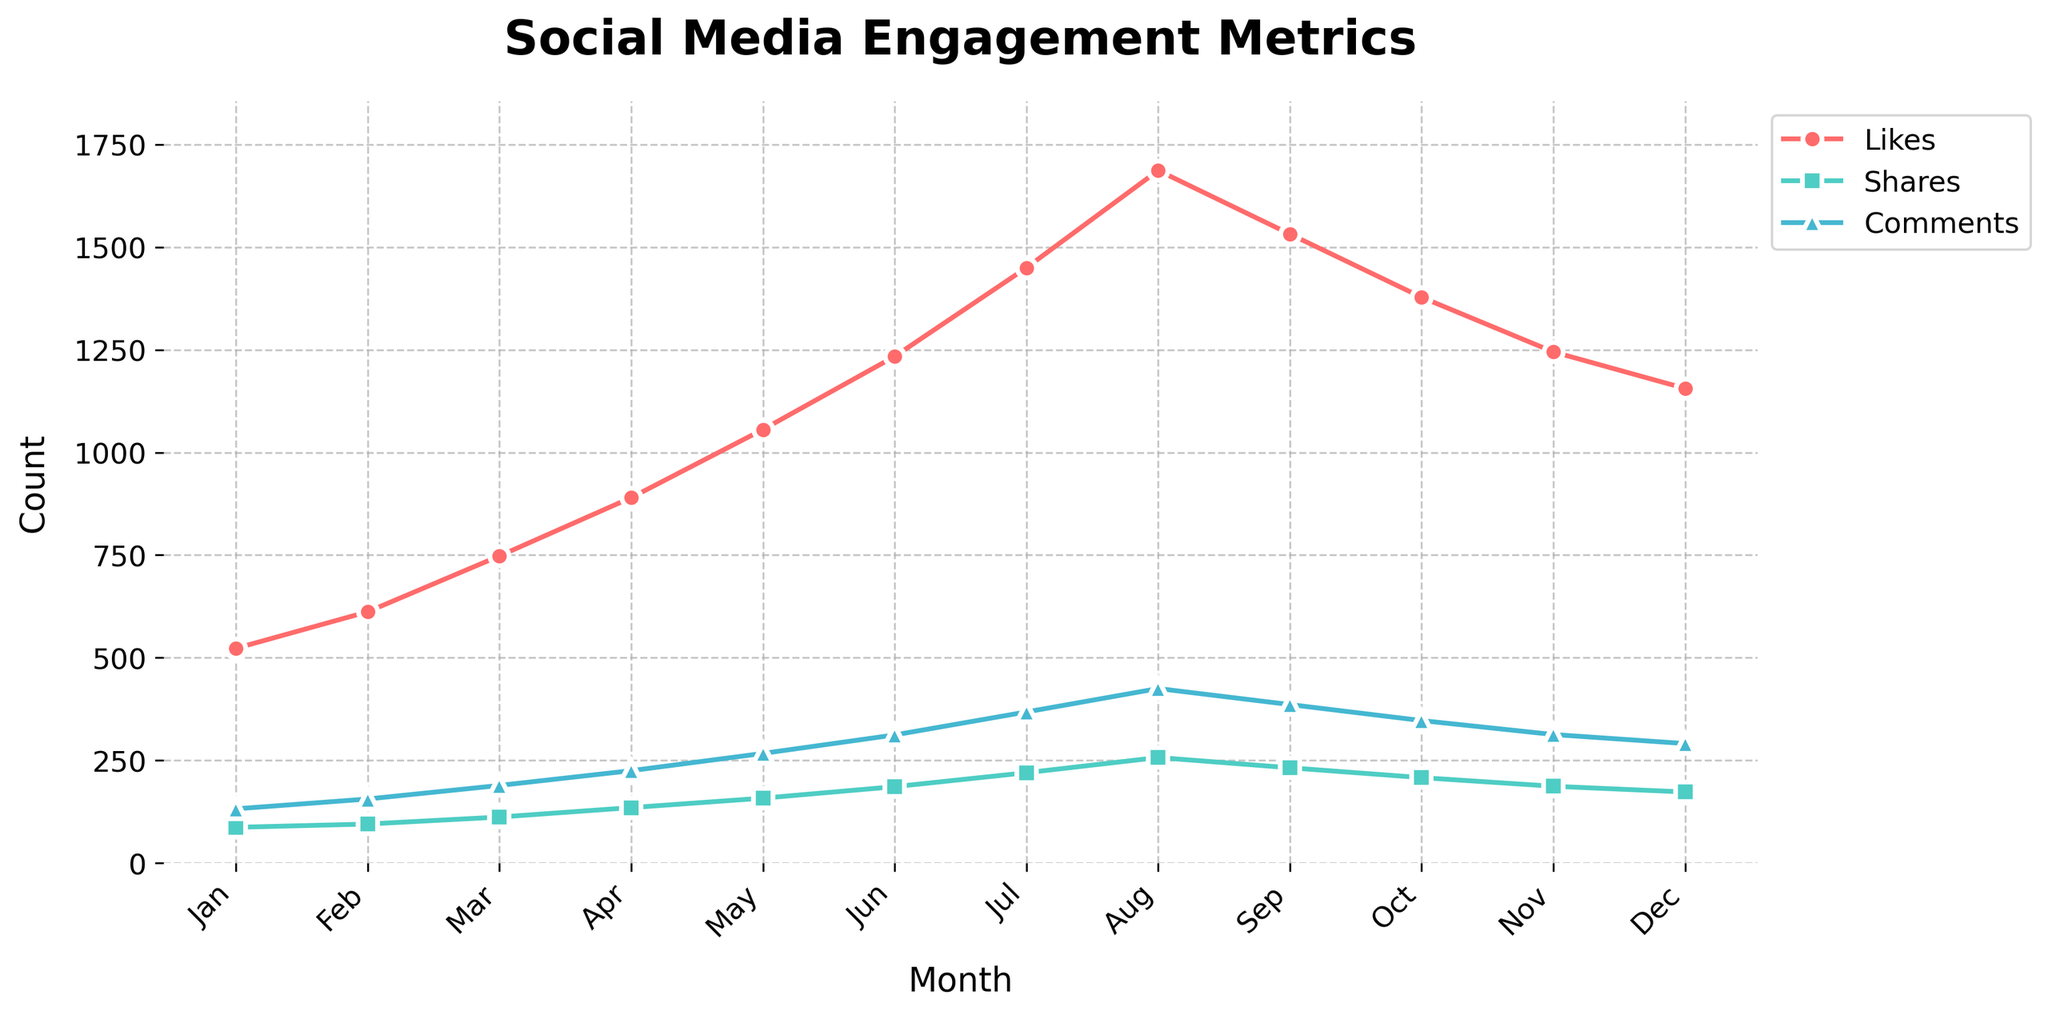What's the overall trend for Likes over the past 12 months? The overall trend can be determined by looking at the line representing Likes. Observing each month's data point, we can see the number of Likes generally increases from January to August and then decreases slightly towards December. This indicates an upward trend followed by a slight decline.
Answer: Increasing with a slight decline towards the end Which month had the highest number of Comments? To determine the month with the highest number of Comments, look for the peak point in the line representing Comments. The peak occurs in August, where the number of Comments is the highest.
Answer: August By how much did Shares increase from January to July? To find out the increase in Shares from January to July, look at the Shares values in these two months. In January, Shares are 87. In July, Shares are 220. The increase is calculated as 220 - 87 = 133.
Answer: 133 How does the number of Likes in June compare to September? Comparing the Likes in June and September involves looking at those two points on the Likes line. June has 1234 Likes, and September has 1532 Likes. Since 1532 is greater than 1234, Likes in September are higher than in June.
Answer: Higher in September What is the average number of Comments in the first half of the year? To calculate the average number of Comments in the first half of the year (January to June), add the number of Comments for each month and then divide by 6. (132 + 156 + 189 + 225 + 267 + 312) / 6 = 208.5.
Answer: 208.5 What is the color used for representing Likes? The color representing Likes can be identified by looking at the visual attribute (color) of the line for Likes. The line representing Likes is red.
Answer: Red Which month saw the largest increase in Shares over the previous month? To determine the largest month-over-month increase in Shares, calculate the difference in Shares for each consecutive month and identify the maximum increase. The differences are 8, 17, 23, 23, 28, 34, 37, -25, -24, -21. The maximum increase is by 37 from July to August.
Answer: July to August What is the difference between the highest and lowest number of Likes in any month? Finding the highest and lowest number of Likes involves identifying the maximum and minimum values on the Likes line. The highest number is 1687 (August) and the lowest is 523 (January). The difference is 1687 - 523 = 1164.
Answer: 1164 How did the Comments change from June to December? To understand the change in Comments from June to December, observe the Comments values in these months. June has 312 Comments, and December has 291 Comments. The change is 291 - 312 = -21, indicating a decrease.
Answer: Decreased by 21 In which two consecutive months did Shares experience no change? Check the values for Shares to identify any two consecutive months showing no change. Shares consistently change every month, so there is no pair of consecutive months with unchanged Shares.
Answer: No consecutive months with no change 